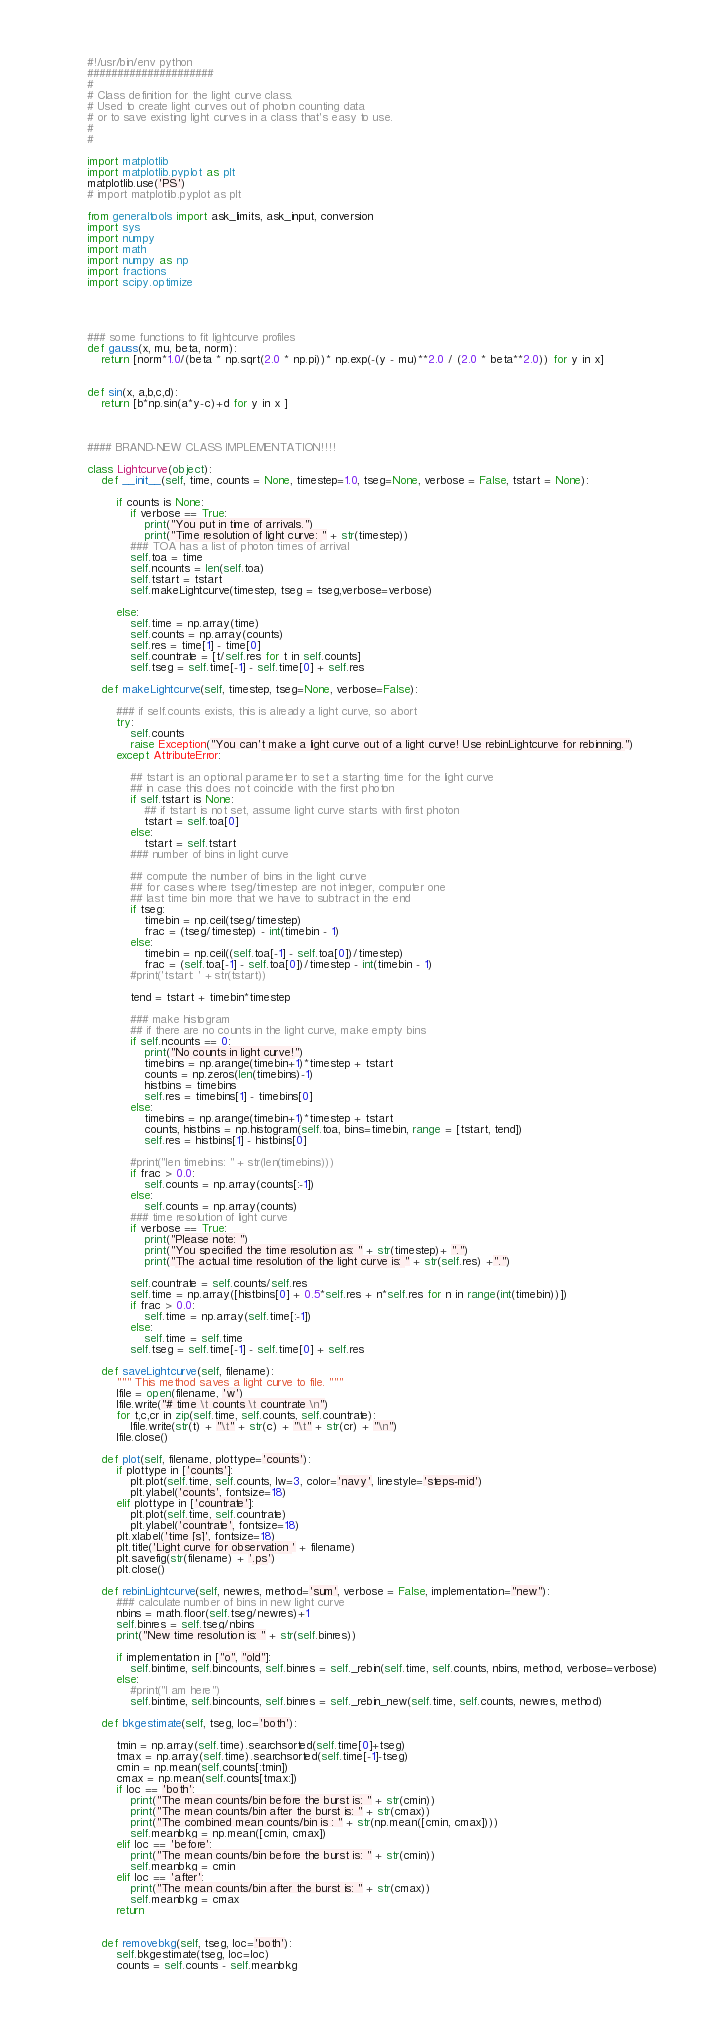<code> <loc_0><loc_0><loc_500><loc_500><_Python_>#!/usr/bin/env python
#####################
#
# Class definition for the light curve class. 
# Used to create light curves out of photon counting data
# or to save existing light curves in a class that's easy to use.
#
#

import matplotlib
import matplotlib.pyplot as plt
matplotlib.use('PS')
# import matplotlib.pyplot as plt

from generaltools import ask_limits, ask_input, conversion
import sys
import numpy
import math
import numpy as np
import fractions
import scipy.optimize




### some functions to fit lightcurve profiles
def gauss(x, mu, beta, norm):
    return [norm*1.0/(beta * np.sqrt(2.0 * np.pi))* np.exp(-(y - mu)**2.0 / (2.0 * beta**2.0)) for y in x]


def sin(x, a,b,c,d):
    return [b*np.sin(a*y-c)+d for y in x ]



#### BRAND-NEW CLASS IMPLEMENTATION!!!!

class Lightcurve(object):
    def __init__(self, time, counts = None, timestep=1.0, tseg=None, verbose = False, tstart = None):

        if counts is None:
            if verbose == True:
                print("You put in time of arrivals.")
                print("Time resolution of light curve: " + str(timestep))
            ### TOA has a list of photon times of arrival
            self.toa = time
            self.ncounts = len(self.toa)
            self.tstart = tstart
            self.makeLightcurve(timestep, tseg = tseg,verbose=verbose)
            
        else:
            self.time = np.array(time)
            self.counts = np.array(counts)
            self.res = time[1] - time[0]
            self.countrate = [t/self.res for t in self.counts]
            self.tseg = self.time[-1] - self.time[0] + self.res

    def makeLightcurve(self, timestep, tseg=None, verbose=False):

        ### if self.counts exists, this is already a light curve, so abort
        try:
            self.counts
            raise Exception("You can't make a light curve out of a light curve! Use rebinLightcurve for rebinning.")
        except AttributeError:

            ## tstart is an optional parameter to set a starting time for the light curve
            ## in case this does not coincide with the first photon
            if self.tstart is None:
                ## if tstart is not set, assume light curve starts with first photon
                tstart = self.toa[0]
            else:
                tstart = self.tstart
            ### number of bins in light curve

            ## compute the number of bins in the light curve
            ## for cases where tseg/timestep are not integer, computer one
            ## last time bin more that we have to subtract in the end
            if tseg:
                timebin = np.ceil(tseg/timestep)
                frac = (tseg/timestep) - int(timebin - 1)
            else:
                timebin = np.ceil((self.toa[-1] - self.toa[0])/timestep)
                frac = (self.toa[-1] - self.toa[0])/timestep - int(timebin - 1)
            #print('tstart: ' + str(tstart))

            tend = tstart + timebin*timestep

            ### make histogram
            ## if there are no counts in the light curve, make empty bins
            if self.ncounts == 0:
                print("No counts in light curve!")
                timebins = np.arange(timebin+1)*timestep + tstart
                counts = np.zeros(len(timebins)-1)
                histbins = timebins
                self.res = timebins[1] - timebins[0]
            else:
                timebins = np.arange(timebin+1)*timestep + tstart
                counts, histbins = np.histogram(self.toa, bins=timebin, range = [tstart, tend])
                self.res = histbins[1] - histbins[0]

            #print("len timebins: " + str(len(timebins)))
            if frac > 0.0:
                self.counts = np.array(counts[:-1])
            else:
                self.counts = np.array(counts) 
            ### time resolution of light curve
            if verbose == True:
                print("Please note: ")
                print("You specified the time resolution as: " + str(timestep)+ ".")
                print("The actual time resolution of the light curve is: " + str(self.res) +".")

            self.countrate = self.counts/self.res
            self.time = np.array([histbins[0] + 0.5*self.res + n*self.res for n in range(int(timebin))])
            if frac > 0.0:
                self.time = np.array(self.time[:-1])
            else:
                self.time = self.time
            self.tseg = self.time[-1] - self.time[0] + self.res

    def saveLightcurve(self, filename):
        """ This method saves a light curve to file. """
        lfile = open(filename, 'w')
        lfile.write("# time \t counts \t countrate \n")
        for t,c,cr in zip(self.time, self.counts, self.countrate):
            lfile.write(str(t) + "\t" + str(c) + "\t" + str(cr) + "\n")
        lfile.close()

    def plot(self, filename, plottype='counts'):
        if plottype in ['counts']:
            plt.plot(self.time, self.counts, lw=3, color='navy', linestyle='steps-mid')
            plt.ylabel('counts', fontsize=18)
        elif plottype in ['countrate']:
            plt.plot(self.time, self.countrate)
            plt.ylabel('countrate', fontsize=18)
        plt.xlabel('time [s]', fontsize=18)
        plt.title('Light curve for observation ' + filename)
        plt.savefig(str(filename) + '.ps')
        plt.close()

    def rebinLightcurve(self, newres, method='sum', verbose = False, implementation="new"):
        ### calculate number of bins in new light curve
        nbins = math.floor(self.tseg/newres)+1
        self.binres = self.tseg/nbins
        print("New time resolution is: " + str(self.binres))

        if implementation in ["o", "old"]:
            self.bintime, self.bincounts, self.binres = self._rebin(self.time, self.counts, nbins, method, verbose=verbose)
        else:
            #print("I am here")
            self.bintime, self.bincounts, self.binres = self._rebin_new(self.time, self.counts, newres, method)

    def bkgestimate(self, tseg, loc='both'):
       
        tmin = np.array(self.time).searchsorted(self.time[0]+tseg)
        tmax = np.array(self.time).searchsorted(self.time[-1]-tseg)
        cmin = np.mean(self.counts[:tmin])
        cmax = np.mean(self.counts[tmax:])
        if loc == 'both':
            print("The mean counts/bin before the burst is: " + str(cmin))
            print("The mean counts/bin after the burst is: " + str(cmax))
            print("The combined mean counts/bin is : " + str(np.mean([cmin, cmax])))
            self.meanbkg = np.mean([cmin, cmax])
        elif loc == 'before':
            print("The mean counts/bin before the burst is: " + str(cmin))
            self.meanbkg = cmin
        elif loc == 'after':
            print("The mean counts/bin after the burst is: " + str(cmax))
            self.meanbkg = cmax
        return


    def removebkg(self, tseg, loc='both'):
        self.bkgestimate(tseg, loc=loc)
        counts = self.counts - self.meanbkg</code> 